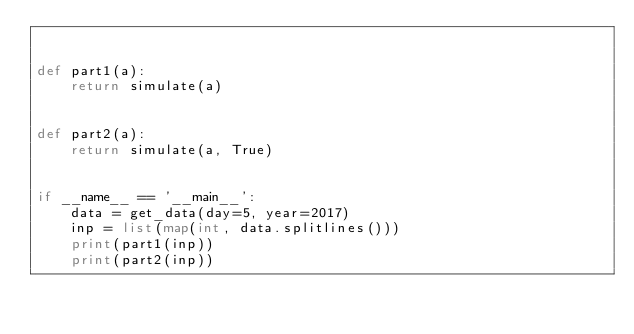<code> <loc_0><loc_0><loc_500><loc_500><_Python_>

def part1(a):
    return simulate(a)


def part2(a):
    return simulate(a, True)


if __name__ == '__main__':
    data = get_data(day=5, year=2017)
    inp = list(map(int, data.splitlines()))
    print(part1(inp))
    print(part2(inp))
</code> 